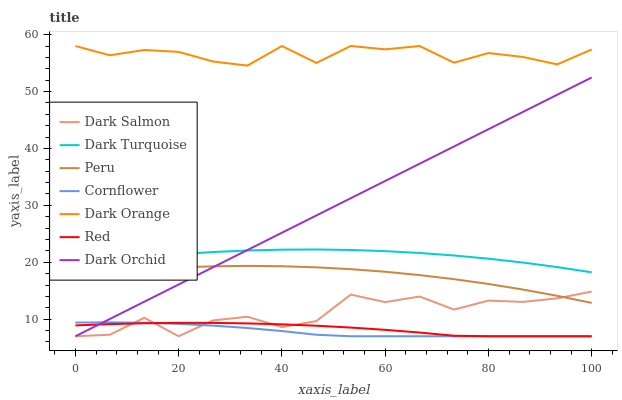Does Cornflower have the minimum area under the curve?
Answer yes or no. Yes. Does Dark Orange have the maximum area under the curve?
Answer yes or no. Yes. Does Dark Turquoise have the minimum area under the curve?
Answer yes or no. No. Does Dark Turquoise have the maximum area under the curve?
Answer yes or no. No. Is Dark Orchid the smoothest?
Answer yes or no. Yes. Is Dark Salmon the roughest?
Answer yes or no. Yes. Is Cornflower the smoothest?
Answer yes or no. No. Is Cornflower the roughest?
Answer yes or no. No. Does Cornflower have the lowest value?
Answer yes or no. Yes. Does Dark Turquoise have the lowest value?
Answer yes or no. No. Does Dark Orange have the highest value?
Answer yes or no. Yes. Does Cornflower have the highest value?
Answer yes or no. No. Is Dark Salmon less than Dark Turquoise?
Answer yes or no. Yes. Is Dark Turquoise greater than Red?
Answer yes or no. Yes. Does Cornflower intersect Dark Salmon?
Answer yes or no. Yes. Is Cornflower less than Dark Salmon?
Answer yes or no. No. Is Cornflower greater than Dark Salmon?
Answer yes or no. No. Does Dark Salmon intersect Dark Turquoise?
Answer yes or no. No. 